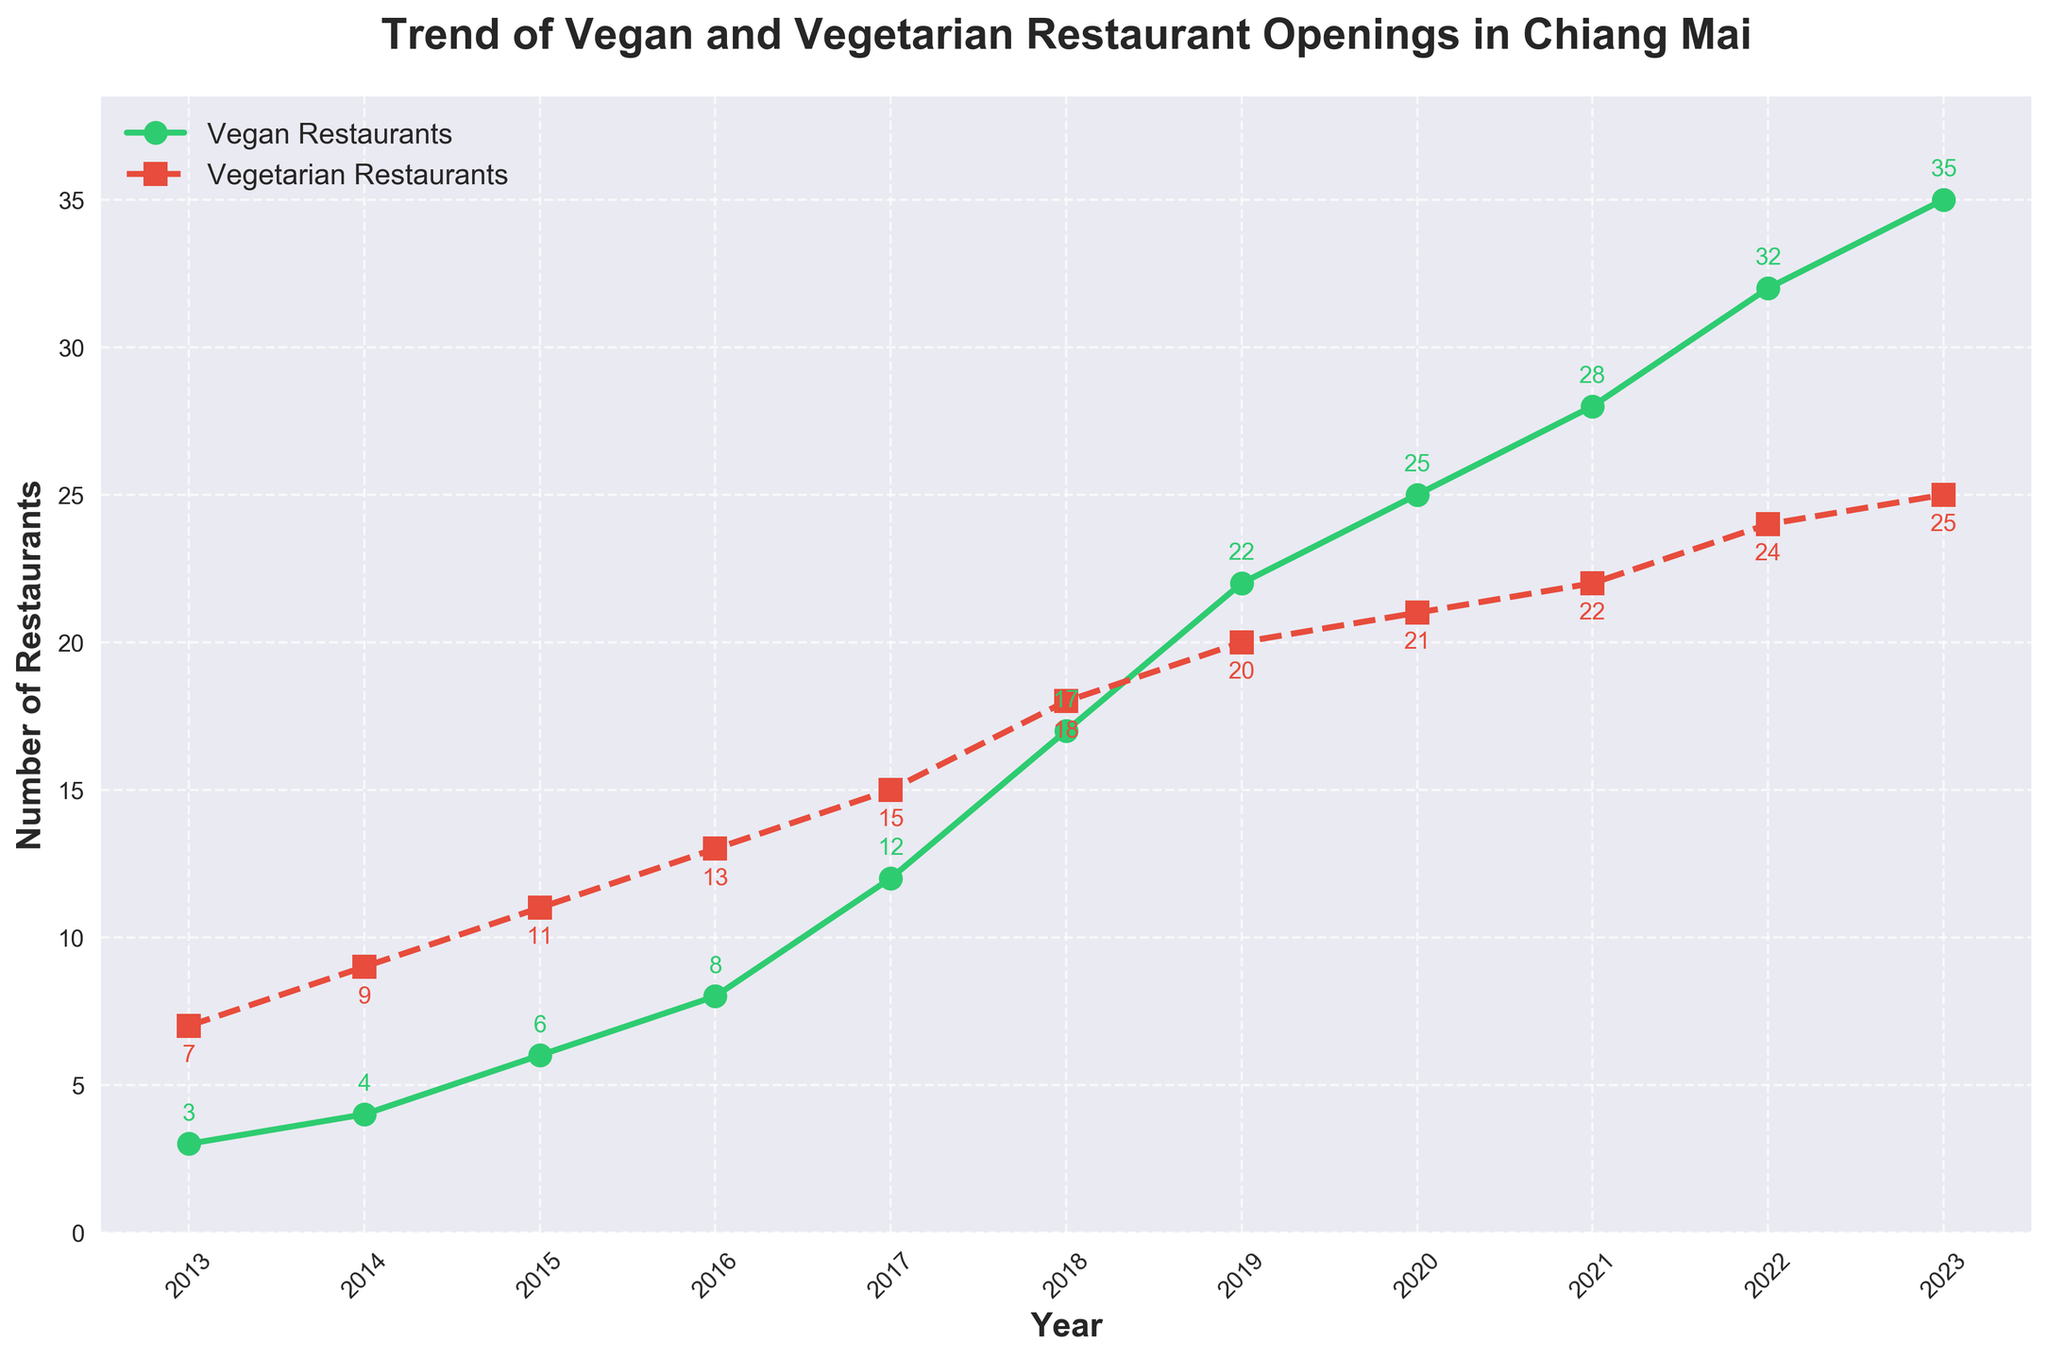What year saw the highest number of vegan restaurant openings? By looking at the line for vegan restaurants, the highest point is at 2023 with 35 openings
Answer: 2023 Which type of restaurant had the greatest increase in number from 2013 to 2023? For vegan restaurants, the increase is 35 - 3 = 32. For vegetarian restaurants, the increase is 25 - 7 = 18. Since 32 > 18, vegan restaurants had the greatest increase
Answer: Vegan restaurants Compare the number of vegan and vegetarian restaurants in 2017. Which had more? In 2017, the number of vegan restaurants is 12 and vegetarian restaurants is 15, so vegetarian restaurants were more
Answer: Vegetarian restaurants What is the total number of vegan and vegetarian restaurants in 2020? In 2020, there are 25 vegan restaurants and 21 vegetarian restaurants. Total is 25 + 21 = 46
Answer: 46 Which year's vegan restaurant openings were equal to the vegetarian restaurant openings in 2014? No year has an equal number of vegan and vegetarian restaurants when you visually compare the lines in the plot
Answer: None What is the average number of vegetarian restaurants over the period shown? The data points for vegetarian restaurants are 7, 9, 11, 13, 15, 18, 20, 21, 22, 24, and 25. Sum them up to get 185, then divide by 11 (number of years). The average is 185 / 11 ≈ 16.82
Answer: 16.82 In which period (years) did both vegan and vegetarian restaurants see a consistent increase every year? By visually tracing the lines, both lines consistently increase from 2013 to 2020
Answer: 2013-2020 What is the total number of vegetarian restaurants opened from 2013 to 2023? Sum the values for vegetarian restaurants: 7 + 9 + 11 + 13 + 15 + 18 + 20 + 21 + 22 + 24 + 25 = 185
Answer: 185 Identify the year when the number of vegan restaurants first exceeded 30. From the plot, 2022 is the first year when vegan restaurants exceed 30
Answer: 2022 